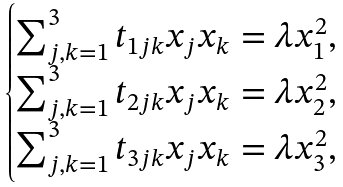Convert formula to latex. <formula><loc_0><loc_0><loc_500><loc_500>\begin{cases} \sum _ { j , k = 1 } ^ { 3 } t _ { 1 j k } x _ { j } x _ { k } = \lambda x _ { 1 } ^ { 2 } , \\ \sum _ { j , k = 1 } ^ { 3 } t _ { 2 j k } x _ { j } x _ { k } = \lambda x _ { 2 } ^ { 2 } , \\ \sum _ { j , k = 1 } ^ { 3 } t _ { 3 j k } x _ { j } x _ { k } = \lambda x _ { 3 } ^ { 2 } , \end{cases}</formula> 